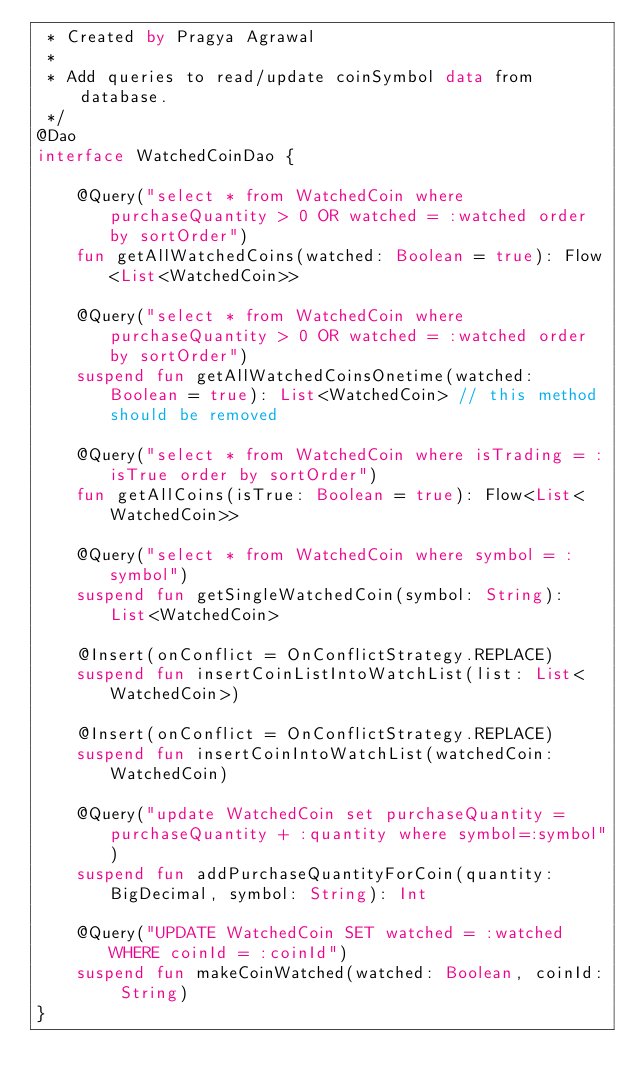<code> <loc_0><loc_0><loc_500><loc_500><_Kotlin_> * Created by Pragya Agrawal
 *
 * Add queries to read/update coinSymbol data from database.
 */
@Dao
interface WatchedCoinDao {

    @Query("select * from WatchedCoin where purchaseQuantity > 0 OR watched = :watched order by sortOrder")
    fun getAllWatchedCoins(watched: Boolean = true): Flow<List<WatchedCoin>>

    @Query("select * from WatchedCoin where purchaseQuantity > 0 OR watched = :watched order by sortOrder")
    suspend fun getAllWatchedCoinsOnetime(watched: Boolean = true): List<WatchedCoin> // this method should be removed

    @Query("select * from WatchedCoin where isTrading = :isTrue order by sortOrder")
    fun getAllCoins(isTrue: Boolean = true): Flow<List<WatchedCoin>>

    @Query("select * from WatchedCoin where symbol = :symbol")
    suspend fun getSingleWatchedCoin(symbol: String): List<WatchedCoin>

    @Insert(onConflict = OnConflictStrategy.REPLACE)
    suspend fun insertCoinListIntoWatchList(list: List<WatchedCoin>)

    @Insert(onConflict = OnConflictStrategy.REPLACE)
    suspend fun insertCoinIntoWatchList(watchedCoin: WatchedCoin)

    @Query("update WatchedCoin set purchaseQuantity = purchaseQuantity + :quantity where symbol=:symbol")
    suspend fun addPurchaseQuantityForCoin(quantity: BigDecimal, symbol: String): Int

    @Query("UPDATE WatchedCoin SET watched = :watched  WHERE coinId = :coinId")
    suspend fun makeCoinWatched(watched: Boolean, coinId: String)
}
</code> 